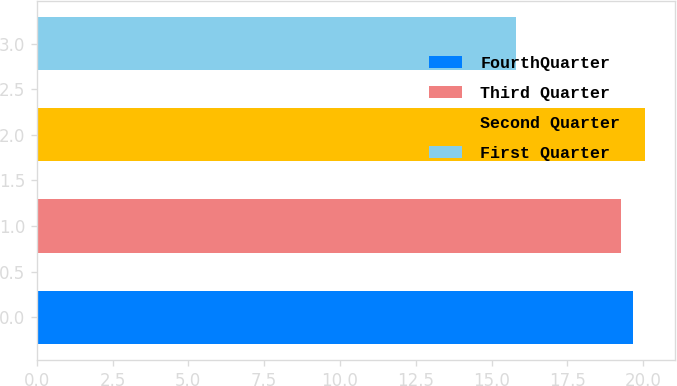Convert chart to OTSL. <chart><loc_0><loc_0><loc_500><loc_500><bar_chart><fcel>FourthQuarter<fcel>Third Quarter<fcel>Second Quarter<fcel>First Quarter<nl><fcel>19.67<fcel>19.28<fcel>20.06<fcel>15.81<nl></chart> 